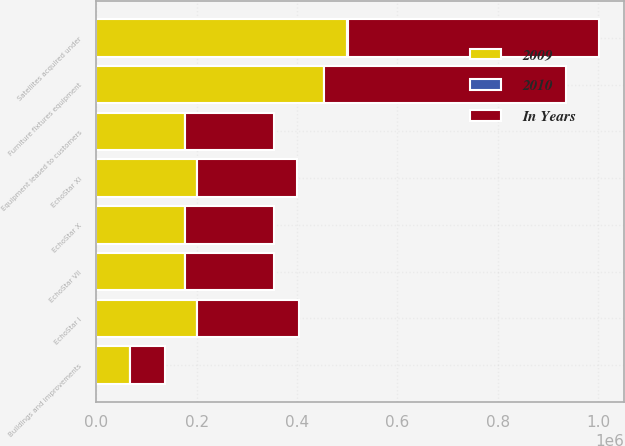Convert chart. <chart><loc_0><loc_0><loc_500><loc_500><stacked_bar_chart><ecel><fcel>Equipment leased to customers<fcel>EchoStar I<fcel>EchoStar VII<fcel>EchoStar X<fcel>EchoStar XI<fcel>Satellites acquired under<fcel>Furniture fixtures equipment<fcel>Buildings and improvements<nl><fcel>2010<fcel>25<fcel>12<fcel>12<fcel>12<fcel>12<fcel>1015<fcel>110<fcel>140<nl><fcel>In Years<fcel>177000<fcel>201607<fcel>177000<fcel>177192<fcel>200198<fcel>499819<fcel>480379<fcel>70471<nl><fcel>2009<fcel>177000<fcel>201607<fcel>177000<fcel>177192<fcel>200198<fcel>499819<fcel>454435<fcel>66612<nl></chart> 